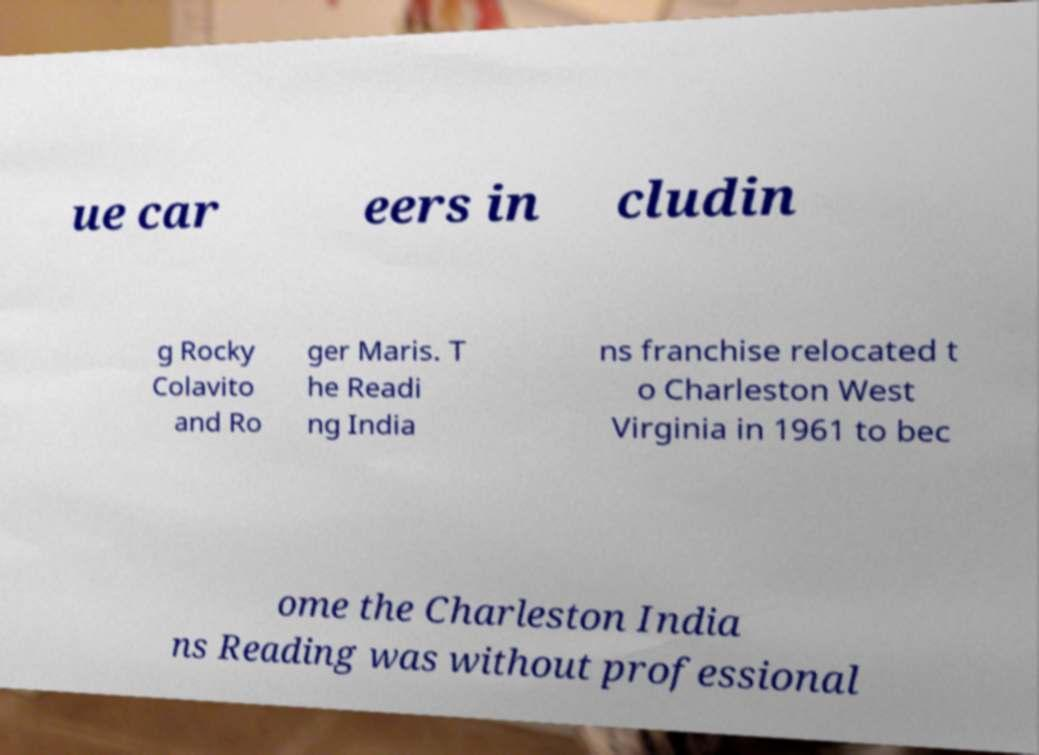For documentation purposes, I need the text within this image transcribed. Could you provide that? ue car eers in cludin g Rocky Colavito and Ro ger Maris. T he Readi ng India ns franchise relocated t o Charleston West Virginia in 1961 to bec ome the Charleston India ns Reading was without professional 